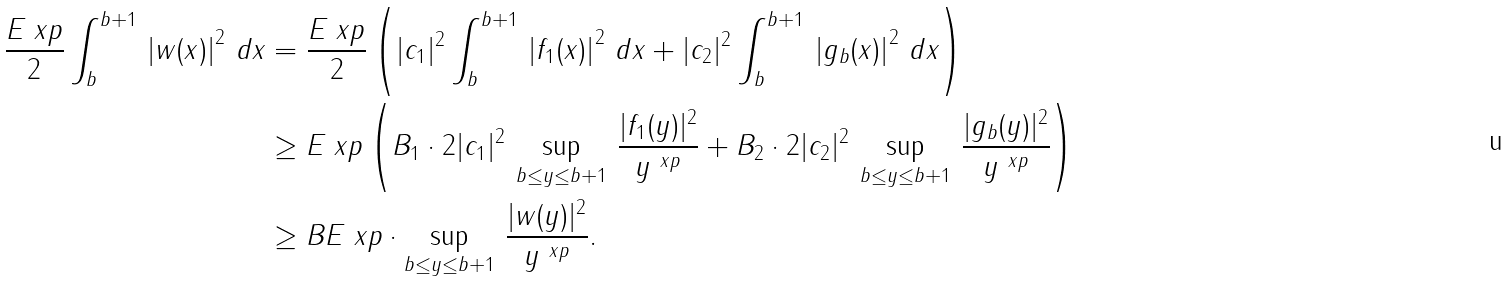Convert formula to latex. <formula><loc_0><loc_0><loc_500><loc_500>\frac { E _ { \ } x p } { 2 } \int _ { b } ^ { b + 1 } \, \left | w ( x ) \right | ^ { 2 } \, d x & = \frac { E _ { \ } x p } { 2 } \left ( | c _ { 1 } | ^ { 2 } \int _ { b } ^ { b + 1 } \, \left | f _ { 1 } ( x ) \right | ^ { 2 } \, d x + | c _ { 2 } | ^ { 2 } \int _ { b } ^ { b + 1 } \, \left | g _ { b } ( x ) \right | ^ { 2 } \, d x \right ) \\ & \geq E _ { \ } x p \left ( B _ { 1 } \cdot 2 | c _ { 1 } | ^ { 2 } \, \sup _ { b \leq y \leq b + 1 } \, \frac { | f _ { 1 } ( y ) | ^ { 2 } } { y ^ { \ x p } } + B _ { 2 } \cdot 2 | c _ { 2 } | ^ { 2 } \, \sup _ { b \leq y \leq b + 1 } \, \frac { | g _ { b } ( y ) | ^ { 2 } } { y ^ { \ x p } } \right ) \\ & \geq B E _ { \ } x p \cdot \sup _ { b \leq y \leq b + 1 } \, \frac { | w ( y ) | ^ { 2 } } { y ^ { \ x p } } .</formula> 